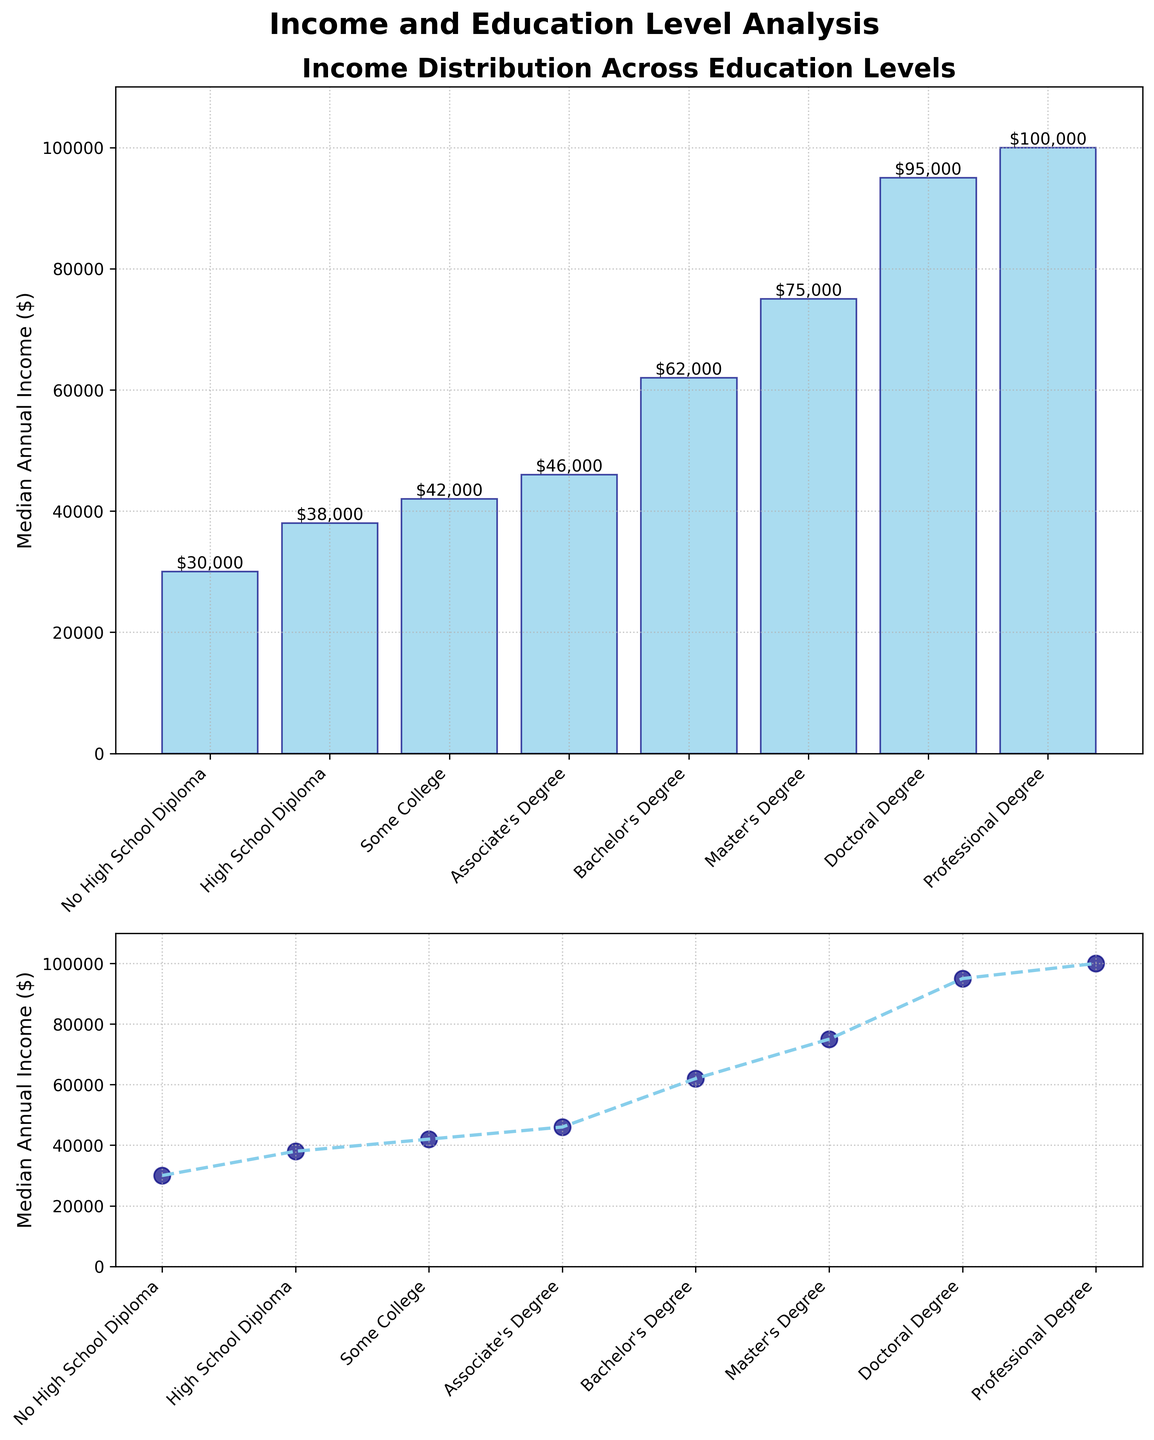What is the title of the combined plot? The title of the combined plot is located at the top and is prominently displayed using a larger and bold font. It reads 'Income and Education Level Analysis'.
Answer: Income and Education Level Analysis How many educational levels are represented in the plot? The educational levels are listed on the x-axis of both subplots. There are eight distinct educational levels shown.
Answer: Eight What is the median annual income for a Bachelor’s Degree? Locate the bar corresponding to "Bachelor's Degree" in the bar plot. The median annual income is displayed on top of this bar as $62,000.
Answer: $62,000 Which education level has the lowest median annual income, and what is that income? Identify the shortest bar in the bar plot. The label "No High School Diploma" and the income displayed on top of the bar is $30,000.
Answer: No High School Diploma, $30,000 What is the income difference between a Master's Degree and an Associate's Degree? Find the incomes for "Master's Degree" ($75,000) and "Associate's Degree" ($46,000) from the bar plot and subtract the smaller value from the larger value: $75,000 - $46,000 = $29,000.
Answer: $29,000 What is the average median annual income across all educational levels represented? Add the median incomes: $30,000 + $38,000 + $42,000 + $46,000 + $62,000 + $75,000 + $95,000 + $100,000 = $488,000. Divide by the number of levels (8): $488,000 / 8 = $61,000.
Answer: $61,000 Which subplot shows the trend of median annual income across education levels more clearly? Compare the representation of the data in both subplots. The scatter plot in the second subplot, with a connected line, shows the upward trend more distinctly.
Answer: Scatter plot Is the median annual income for a Doctoral Degree higher than for a Bachelor’s Degree? Check the respective bars in the bar plot. The Doctoral Degree bar is higher, showing an income of $95,000 versus the Bachelor’s Degree at $62,000.
Answer: Yes What is the difference in median annual income between the highest and lowest education levels? Locate and compare the highest bar (Professional Degree, $100,000) and the lowest bar (No High School Diploma, $30,000). Calculate $100,000 - $30,000 = $70,000.
Answer: $70,000 How does the grid appearance contribute to the readability of the data in the plots? The grid lines, which are displayed as dotted lines throughout both subplots, help in visual alignment and comparison of income values across different education levels.
Answer: It enhances readability 